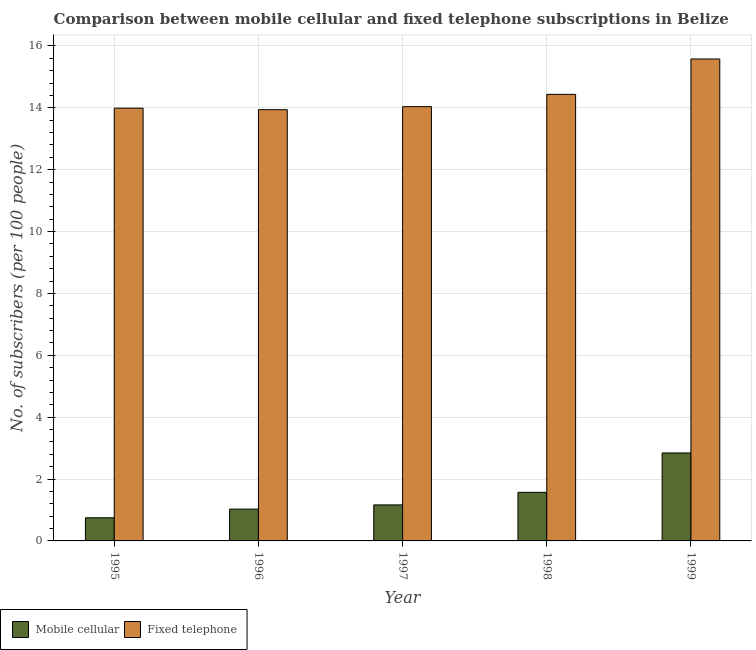How many groups of bars are there?
Give a very brief answer. 5. Are the number of bars per tick equal to the number of legend labels?
Make the answer very short. Yes. How many bars are there on the 4th tick from the right?
Your response must be concise. 2. What is the label of the 4th group of bars from the left?
Make the answer very short. 1998. What is the number of mobile cellular subscribers in 1996?
Give a very brief answer. 1.03. Across all years, what is the maximum number of mobile cellular subscribers?
Your answer should be very brief. 2.84. Across all years, what is the minimum number of mobile cellular subscribers?
Give a very brief answer. 0.75. In which year was the number of fixed telephone subscribers maximum?
Provide a succinct answer. 1999. In which year was the number of mobile cellular subscribers minimum?
Your answer should be very brief. 1995. What is the total number of fixed telephone subscribers in the graph?
Your response must be concise. 71.97. What is the difference between the number of fixed telephone subscribers in 1997 and that in 1999?
Offer a terse response. -1.54. What is the difference between the number of fixed telephone subscribers in 1995 and the number of mobile cellular subscribers in 1999?
Provide a short and direct response. -1.59. What is the average number of mobile cellular subscribers per year?
Your answer should be very brief. 1.47. In how many years, is the number of fixed telephone subscribers greater than 4.4?
Offer a terse response. 5. What is the ratio of the number of mobile cellular subscribers in 1997 to that in 1998?
Give a very brief answer. 0.74. Is the number of fixed telephone subscribers in 1998 less than that in 1999?
Your answer should be compact. Yes. What is the difference between the highest and the second highest number of fixed telephone subscribers?
Provide a short and direct response. 1.14. What is the difference between the highest and the lowest number of fixed telephone subscribers?
Provide a succinct answer. 1.64. In how many years, is the number of fixed telephone subscribers greater than the average number of fixed telephone subscribers taken over all years?
Keep it short and to the point. 2. Is the sum of the number of fixed telephone subscribers in 1995 and 1996 greater than the maximum number of mobile cellular subscribers across all years?
Offer a very short reply. Yes. What does the 1st bar from the left in 1995 represents?
Offer a very short reply. Mobile cellular. What does the 1st bar from the right in 1995 represents?
Your response must be concise. Fixed telephone. Are all the bars in the graph horizontal?
Offer a terse response. No. How many years are there in the graph?
Offer a very short reply. 5. What is the difference between two consecutive major ticks on the Y-axis?
Your answer should be compact. 2. Are the values on the major ticks of Y-axis written in scientific E-notation?
Keep it short and to the point. No. Does the graph contain any zero values?
Provide a short and direct response. No. Does the graph contain grids?
Provide a short and direct response. Yes. What is the title of the graph?
Make the answer very short. Comparison between mobile cellular and fixed telephone subscriptions in Belize. Does "Male population" appear as one of the legend labels in the graph?
Provide a succinct answer. No. What is the label or title of the Y-axis?
Keep it short and to the point. No. of subscribers (per 100 people). What is the No. of subscribers (per 100 people) of Mobile cellular in 1995?
Offer a terse response. 0.75. What is the No. of subscribers (per 100 people) in Fixed telephone in 1995?
Ensure brevity in your answer.  13.99. What is the No. of subscribers (per 100 people) in Mobile cellular in 1996?
Your response must be concise. 1.03. What is the No. of subscribers (per 100 people) of Fixed telephone in 1996?
Provide a succinct answer. 13.94. What is the No. of subscribers (per 100 people) in Mobile cellular in 1997?
Ensure brevity in your answer.  1.16. What is the No. of subscribers (per 100 people) in Fixed telephone in 1997?
Your response must be concise. 14.04. What is the No. of subscribers (per 100 people) of Mobile cellular in 1998?
Your answer should be compact. 1.57. What is the No. of subscribers (per 100 people) of Fixed telephone in 1998?
Offer a very short reply. 14.43. What is the No. of subscribers (per 100 people) of Mobile cellular in 1999?
Make the answer very short. 2.84. What is the No. of subscribers (per 100 people) of Fixed telephone in 1999?
Your answer should be compact. 15.58. Across all years, what is the maximum No. of subscribers (per 100 people) of Mobile cellular?
Give a very brief answer. 2.84. Across all years, what is the maximum No. of subscribers (per 100 people) of Fixed telephone?
Offer a terse response. 15.58. Across all years, what is the minimum No. of subscribers (per 100 people) in Mobile cellular?
Keep it short and to the point. 0.75. Across all years, what is the minimum No. of subscribers (per 100 people) of Fixed telephone?
Your answer should be very brief. 13.94. What is the total No. of subscribers (per 100 people) in Mobile cellular in the graph?
Your answer should be very brief. 7.35. What is the total No. of subscribers (per 100 people) of Fixed telephone in the graph?
Offer a terse response. 71.97. What is the difference between the No. of subscribers (per 100 people) in Mobile cellular in 1995 and that in 1996?
Your response must be concise. -0.28. What is the difference between the No. of subscribers (per 100 people) in Fixed telephone in 1995 and that in 1996?
Give a very brief answer. 0.05. What is the difference between the No. of subscribers (per 100 people) in Mobile cellular in 1995 and that in 1997?
Provide a succinct answer. -0.42. What is the difference between the No. of subscribers (per 100 people) in Fixed telephone in 1995 and that in 1997?
Keep it short and to the point. -0.05. What is the difference between the No. of subscribers (per 100 people) of Mobile cellular in 1995 and that in 1998?
Keep it short and to the point. -0.82. What is the difference between the No. of subscribers (per 100 people) in Fixed telephone in 1995 and that in 1998?
Provide a short and direct response. -0.45. What is the difference between the No. of subscribers (per 100 people) of Mobile cellular in 1995 and that in 1999?
Your answer should be compact. -2.1. What is the difference between the No. of subscribers (per 100 people) in Fixed telephone in 1995 and that in 1999?
Offer a very short reply. -1.59. What is the difference between the No. of subscribers (per 100 people) of Mobile cellular in 1996 and that in 1997?
Make the answer very short. -0.14. What is the difference between the No. of subscribers (per 100 people) of Fixed telephone in 1996 and that in 1997?
Your answer should be compact. -0.1. What is the difference between the No. of subscribers (per 100 people) of Mobile cellular in 1996 and that in 1998?
Make the answer very short. -0.54. What is the difference between the No. of subscribers (per 100 people) of Fixed telephone in 1996 and that in 1998?
Keep it short and to the point. -0.5. What is the difference between the No. of subscribers (per 100 people) in Mobile cellular in 1996 and that in 1999?
Make the answer very short. -1.81. What is the difference between the No. of subscribers (per 100 people) of Fixed telephone in 1996 and that in 1999?
Provide a succinct answer. -1.64. What is the difference between the No. of subscribers (per 100 people) of Mobile cellular in 1997 and that in 1998?
Ensure brevity in your answer.  -0.41. What is the difference between the No. of subscribers (per 100 people) of Fixed telephone in 1997 and that in 1998?
Offer a terse response. -0.4. What is the difference between the No. of subscribers (per 100 people) of Mobile cellular in 1997 and that in 1999?
Your answer should be compact. -1.68. What is the difference between the No. of subscribers (per 100 people) in Fixed telephone in 1997 and that in 1999?
Make the answer very short. -1.54. What is the difference between the No. of subscribers (per 100 people) of Mobile cellular in 1998 and that in 1999?
Give a very brief answer. -1.27. What is the difference between the No. of subscribers (per 100 people) of Fixed telephone in 1998 and that in 1999?
Ensure brevity in your answer.  -1.14. What is the difference between the No. of subscribers (per 100 people) of Mobile cellular in 1995 and the No. of subscribers (per 100 people) of Fixed telephone in 1996?
Make the answer very short. -13.19. What is the difference between the No. of subscribers (per 100 people) of Mobile cellular in 1995 and the No. of subscribers (per 100 people) of Fixed telephone in 1997?
Keep it short and to the point. -13.29. What is the difference between the No. of subscribers (per 100 people) of Mobile cellular in 1995 and the No. of subscribers (per 100 people) of Fixed telephone in 1998?
Offer a terse response. -13.69. What is the difference between the No. of subscribers (per 100 people) in Mobile cellular in 1995 and the No. of subscribers (per 100 people) in Fixed telephone in 1999?
Your answer should be compact. -14.83. What is the difference between the No. of subscribers (per 100 people) of Mobile cellular in 1996 and the No. of subscribers (per 100 people) of Fixed telephone in 1997?
Keep it short and to the point. -13.01. What is the difference between the No. of subscribers (per 100 people) in Mobile cellular in 1996 and the No. of subscribers (per 100 people) in Fixed telephone in 1998?
Ensure brevity in your answer.  -13.4. What is the difference between the No. of subscribers (per 100 people) in Mobile cellular in 1996 and the No. of subscribers (per 100 people) in Fixed telephone in 1999?
Your answer should be compact. -14.55. What is the difference between the No. of subscribers (per 100 people) of Mobile cellular in 1997 and the No. of subscribers (per 100 people) of Fixed telephone in 1998?
Make the answer very short. -13.27. What is the difference between the No. of subscribers (per 100 people) of Mobile cellular in 1997 and the No. of subscribers (per 100 people) of Fixed telephone in 1999?
Your answer should be very brief. -14.41. What is the difference between the No. of subscribers (per 100 people) of Mobile cellular in 1998 and the No. of subscribers (per 100 people) of Fixed telephone in 1999?
Your answer should be very brief. -14.01. What is the average No. of subscribers (per 100 people) of Mobile cellular per year?
Keep it short and to the point. 1.47. What is the average No. of subscribers (per 100 people) of Fixed telephone per year?
Your answer should be compact. 14.39. In the year 1995, what is the difference between the No. of subscribers (per 100 people) in Mobile cellular and No. of subscribers (per 100 people) in Fixed telephone?
Make the answer very short. -13.24. In the year 1996, what is the difference between the No. of subscribers (per 100 people) in Mobile cellular and No. of subscribers (per 100 people) in Fixed telephone?
Make the answer very short. -12.91. In the year 1997, what is the difference between the No. of subscribers (per 100 people) of Mobile cellular and No. of subscribers (per 100 people) of Fixed telephone?
Make the answer very short. -12.87. In the year 1998, what is the difference between the No. of subscribers (per 100 people) in Mobile cellular and No. of subscribers (per 100 people) in Fixed telephone?
Offer a very short reply. -12.86. In the year 1999, what is the difference between the No. of subscribers (per 100 people) of Mobile cellular and No. of subscribers (per 100 people) of Fixed telephone?
Give a very brief answer. -12.73. What is the ratio of the No. of subscribers (per 100 people) of Mobile cellular in 1995 to that in 1996?
Ensure brevity in your answer.  0.73. What is the ratio of the No. of subscribers (per 100 people) of Fixed telephone in 1995 to that in 1996?
Ensure brevity in your answer.  1. What is the ratio of the No. of subscribers (per 100 people) in Mobile cellular in 1995 to that in 1997?
Your response must be concise. 0.64. What is the ratio of the No. of subscribers (per 100 people) in Fixed telephone in 1995 to that in 1997?
Your answer should be compact. 1. What is the ratio of the No. of subscribers (per 100 people) of Mobile cellular in 1995 to that in 1998?
Your answer should be very brief. 0.48. What is the ratio of the No. of subscribers (per 100 people) in Mobile cellular in 1995 to that in 1999?
Make the answer very short. 0.26. What is the ratio of the No. of subscribers (per 100 people) in Fixed telephone in 1995 to that in 1999?
Give a very brief answer. 0.9. What is the ratio of the No. of subscribers (per 100 people) of Mobile cellular in 1996 to that in 1997?
Give a very brief answer. 0.88. What is the ratio of the No. of subscribers (per 100 people) in Fixed telephone in 1996 to that in 1997?
Keep it short and to the point. 0.99. What is the ratio of the No. of subscribers (per 100 people) in Mobile cellular in 1996 to that in 1998?
Provide a succinct answer. 0.65. What is the ratio of the No. of subscribers (per 100 people) in Fixed telephone in 1996 to that in 1998?
Give a very brief answer. 0.97. What is the ratio of the No. of subscribers (per 100 people) in Mobile cellular in 1996 to that in 1999?
Offer a very short reply. 0.36. What is the ratio of the No. of subscribers (per 100 people) of Fixed telephone in 1996 to that in 1999?
Make the answer very short. 0.89. What is the ratio of the No. of subscribers (per 100 people) in Mobile cellular in 1997 to that in 1998?
Make the answer very short. 0.74. What is the ratio of the No. of subscribers (per 100 people) in Fixed telephone in 1997 to that in 1998?
Offer a terse response. 0.97. What is the ratio of the No. of subscribers (per 100 people) of Mobile cellular in 1997 to that in 1999?
Keep it short and to the point. 0.41. What is the ratio of the No. of subscribers (per 100 people) of Fixed telephone in 1997 to that in 1999?
Offer a terse response. 0.9. What is the ratio of the No. of subscribers (per 100 people) of Mobile cellular in 1998 to that in 1999?
Offer a terse response. 0.55. What is the ratio of the No. of subscribers (per 100 people) of Fixed telephone in 1998 to that in 1999?
Make the answer very short. 0.93. What is the difference between the highest and the second highest No. of subscribers (per 100 people) in Mobile cellular?
Your answer should be compact. 1.27. What is the difference between the highest and the second highest No. of subscribers (per 100 people) in Fixed telephone?
Provide a succinct answer. 1.14. What is the difference between the highest and the lowest No. of subscribers (per 100 people) of Mobile cellular?
Provide a succinct answer. 2.1. What is the difference between the highest and the lowest No. of subscribers (per 100 people) in Fixed telephone?
Give a very brief answer. 1.64. 